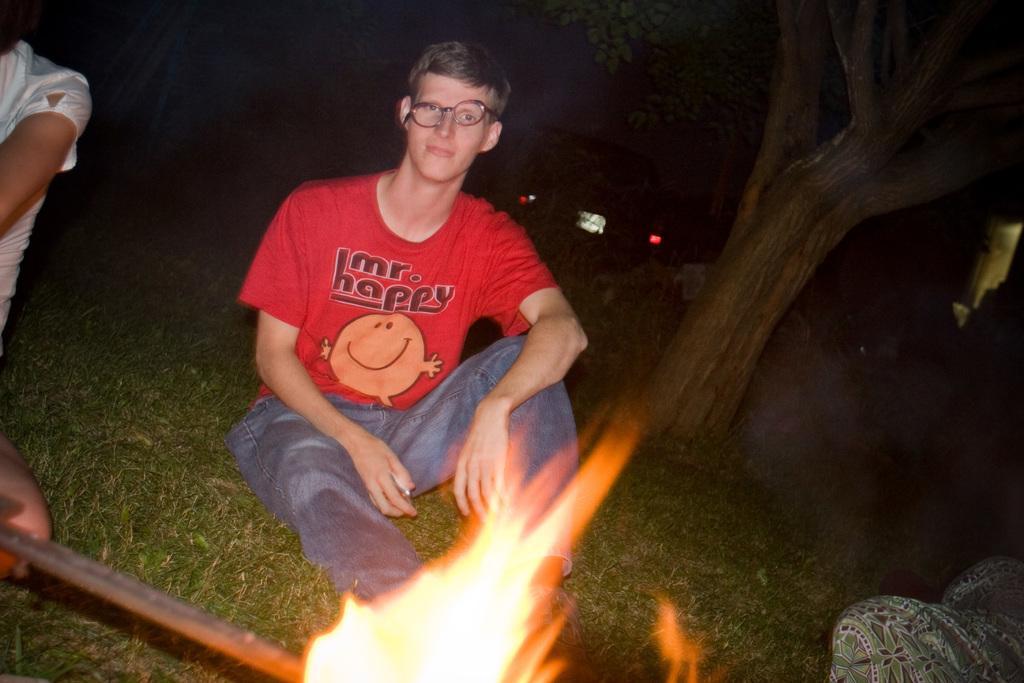Can you describe this image briefly? In the image we can see a man sitting, wearing clothes, spectacles and holding an object in hand. Beside the man there are other people sitting. Here we can see flame, grass, tree and the background is dark.  